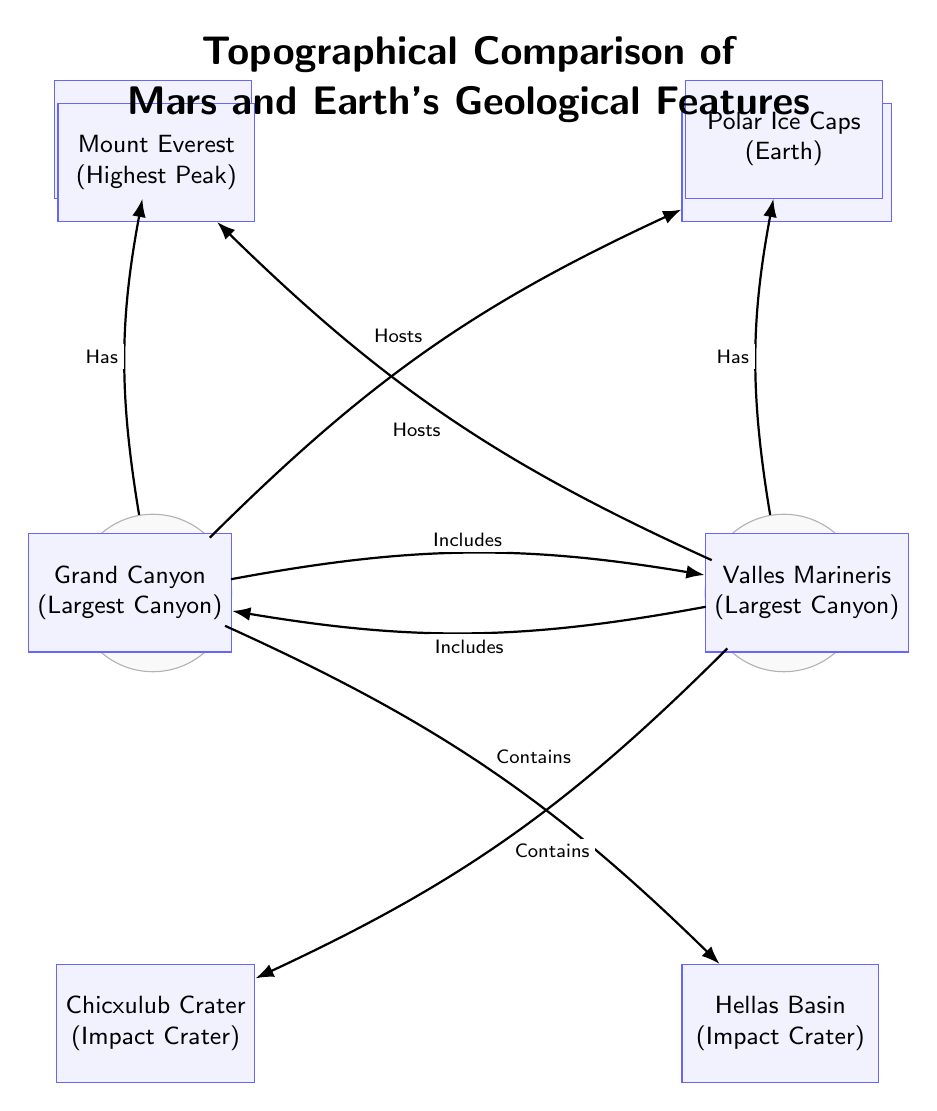What geological feature is the largest volcano on Mars? The diagram indicates that Olympus Mons is the largest volcano on Mars, as labeled in the node connected to Mars.
Answer: Olympus Mons How many geological features are listed for Earth? By counting the nodes connected to Earth, there are four features outlined in the diagram: Mount Everest, Grand Canyon, Chicxulub Crater, and Polar Ice Caps.
Answer: Four Which planet has the largest canyon? The diagram specifies that Valles Marineris is labeled as the largest canyon and it is connected to Mars, indicating that Mars has this geological feature.
Answer: Mars What does Mars "Host"? The diagram shows that Olympus Mons is listed as a feature that Mars "Hosts," directly connecting it to the planet.
Answer: Olympus Mons Which feature is common to both planets? The diagram mentions Polar Ice Caps, one for each planet, showing that this feature exists on both Mars and Earth.
Answer: Polar Ice Caps What is the relationship between Earth and the Grand Canyon? The edge connecting Earth to the Grand Canyon is labeled "Includes," indicating that the Grand Canyon is a notable feature that Earth encompasses.
Answer: Includes Which planet contains the Hellas Basin? The diagram shows that Hellas Basin is connected to Mars, indicating it is a feature contained within this planet.
Answer: Mars What type of geological feature is the Chicxulub Crater? The diagram identifies the Chicxulub Crater as an impact crater, which is a specific classification of geological feature shown in the chart.
Answer: Impact Crater Which planet hosts the highest peak? The diagram clearly states that Mount Everest is connected to Earth and is labeled as the highest peak, thus indicating that Earth hosts this feature.
Answer: Earth 